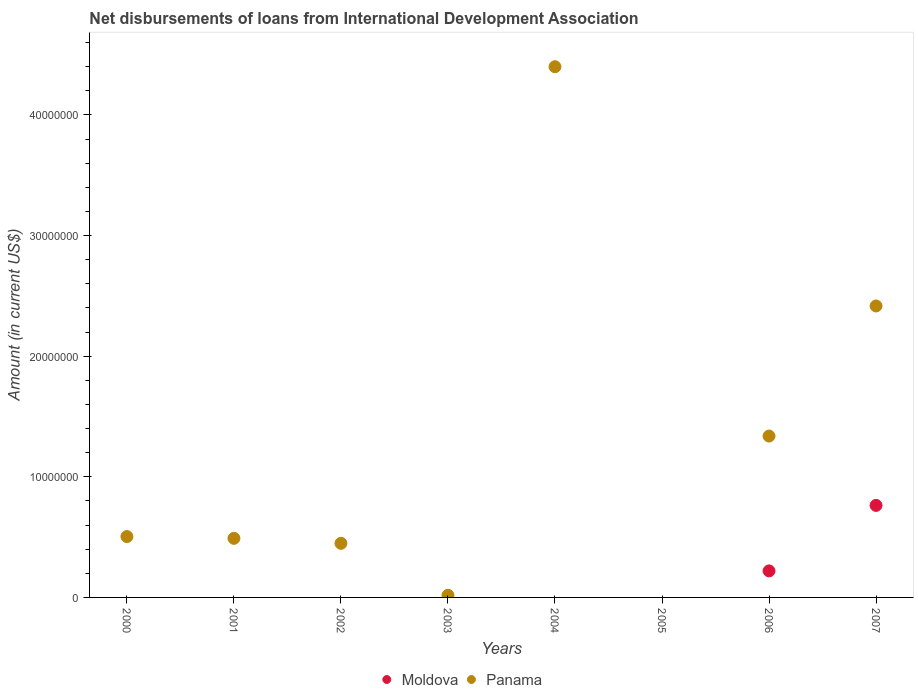Is the number of dotlines equal to the number of legend labels?
Offer a very short reply. No. Across all years, what is the maximum amount of loans disbursed in Panama?
Provide a succinct answer. 4.40e+07. What is the total amount of loans disbursed in Panama in the graph?
Keep it short and to the point. 9.61e+07. What is the difference between the amount of loans disbursed in Panama in 2004 and that in 2006?
Provide a succinct answer. 3.06e+07. What is the difference between the amount of loans disbursed in Panama in 2004 and the amount of loans disbursed in Moldova in 2000?
Make the answer very short. 4.40e+07. What is the average amount of loans disbursed in Panama per year?
Offer a very short reply. 1.20e+07. In how many years, is the amount of loans disbursed in Moldova greater than 30000000 US$?
Keep it short and to the point. 0. What is the ratio of the amount of loans disbursed in Panama in 2000 to that in 2007?
Offer a terse response. 0.21. What is the difference between the highest and the second highest amount of loans disbursed in Panama?
Give a very brief answer. 1.98e+07. What is the difference between the highest and the lowest amount of loans disbursed in Panama?
Your answer should be very brief. 4.40e+07. Is the sum of the amount of loans disbursed in Panama in 2006 and 2007 greater than the maximum amount of loans disbursed in Moldova across all years?
Provide a short and direct response. Yes. Is the amount of loans disbursed in Moldova strictly greater than the amount of loans disbursed in Panama over the years?
Your answer should be very brief. No. How many dotlines are there?
Offer a terse response. 2. Does the graph contain any zero values?
Provide a short and direct response. Yes. Does the graph contain grids?
Provide a succinct answer. No. How many legend labels are there?
Your answer should be very brief. 2. How are the legend labels stacked?
Ensure brevity in your answer.  Horizontal. What is the title of the graph?
Provide a short and direct response. Net disbursements of loans from International Development Association. What is the label or title of the X-axis?
Provide a short and direct response. Years. What is the label or title of the Y-axis?
Give a very brief answer. Amount (in current US$). What is the Amount (in current US$) of Moldova in 2000?
Your response must be concise. 0. What is the Amount (in current US$) of Panama in 2000?
Offer a terse response. 5.05e+06. What is the Amount (in current US$) of Panama in 2001?
Your answer should be very brief. 4.90e+06. What is the Amount (in current US$) of Moldova in 2002?
Provide a short and direct response. 0. What is the Amount (in current US$) of Panama in 2002?
Your answer should be very brief. 4.48e+06. What is the Amount (in current US$) of Moldova in 2003?
Provide a short and direct response. 0. What is the Amount (in current US$) in Panama in 2004?
Your answer should be very brief. 4.40e+07. What is the Amount (in current US$) of Moldova in 2006?
Ensure brevity in your answer.  2.20e+06. What is the Amount (in current US$) of Panama in 2006?
Make the answer very short. 1.34e+07. What is the Amount (in current US$) of Moldova in 2007?
Keep it short and to the point. 7.63e+06. What is the Amount (in current US$) in Panama in 2007?
Your answer should be compact. 2.42e+07. Across all years, what is the maximum Amount (in current US$) in Moldova?
Give a very brief answer. 7.63e+06. Across all years, what is the maximum Amount (in current US$) in Panama?
Your answer should be compact. 4.40e+07. Across all years, what is the minimum Amount (in current US$) of Panama?
Your response must be concise. 0. What is the total Amount (in current US$) in Moldova in the graph?
Ensure brevity in your answer.  9.83e+06. What is the total Amount (in current US$) of Panama in the graph?
Your answer should be compact. 9.61e+07. What is the difference between the Amount (in current US$) in Panama in 2000 and that in 2001?
Make the answer very short. 1.49e+05. What is the difference between the Amount (in current US$) of Panama in 2000 and that in 2002?
Provide a short and direct response. 5.61e+05. What is the difference between the Amount (in current US$) of Panama in 2000 and that in 2003?
Make the answer very short. 4.87e+06. What is the difference between the Amount (in current US$) of Panama in 2000 and that in 2004?
Your answer should be compact. -3.90e+07. What is the difference between the Amount (in current US$) of Panama in 2000 and that in 2006?
Provide a succinct answer. -8.33e+06. What is the difference between the Amount (in current US$) in Panama in 2000 and that in 2007?
Give a very brief answer. -1.91e+07. What is the difference between the Amount (in current US$) in Panama in 2001 and that in 2002?
Your response must be concise. 4.12e+05. What is the difference between the Amount (in current US$) in Panama in 2001 and that in 2003?
Provide a short and direct response. 4.72e+06. What is the difference between the Amount (in current US$) of Panama in 2001 and that in 2004?
Offer a terse response. -3.91e+07. What is the difference between the Amount (in current US$) of Panama in 2001 and that in 2006?
Give a very brief answer. -8.48e+06. What is the difference between the Amount (in current US$) in Panama in 2001 and that in 2007?
Provide a short and direct response. -1.93e+07. What is the difference between the Amount (in current US$) in Panama in 2002 and that in 2003?
Make the answer very short. 4.30e+06. What is the difference between the Amount (in current US$) in Panama in 2002 and that in 2004?
Your answer should be very brief. -3.95e+07. What is the difference between the Amount (in current US$) of Panama in 2002 and that in 2006?
Give a very brief answer. -8.89e+06. What is the difference between the Amount (in current US$) in Panama in 2002 and that in 2007?
Offer a very short reply. -1.97e+07. What is the difference between the Amount (in current US$) of Panama in 2003 and that in 2004?
Offer a very short reply. -4.38e+07. What is the difference between the Amount (in current US$) in Panama in 2003 and that in 2006?
Keep it short and to the point. -1.32e+07. What is the difference between the Amount (in current US$) of Panama in 2003 and that in 2007?
Provide a short and direct response. -2.40e+07. What is the difference between the Amount (in current US$) of Panama in 2004 and that in 2006?
Keep it short and to the point. 3.06e+07. What is the difference between the Amount (in current US$) of Panama in 2004 and that in 2007?
Your answer should be compact. 1.98e+07. What is the difference between the Amount (in current US$) in Moldova in 2006 and that in 2007?
Offer a terse response. -5.43e+06. What is the difference between the Amount (in current US$) in Panama in 2006 and that in 2007?
Give a very brief answer. -1.08e+07. What is the difference between the Amount (in current US$) of Moldova in 2006 and the Amount (in current US$) of Panama in 2007?
Your answer should be very brief. -2.20e+07. What is the average Amount (in current US$) of Moldova per year?
Ensure brevity in your answer.  1.23e+06. What is the average Amount (in current US$) of Panama per year?
Your response must be concise. 1.20e+07. In the year 2006, what is the difference between the Amount (in current US$) of Moldova and Amount (in current US$) of Panama?
Your response must be concise. -1.12e+07. In the year 2007, what is the difference between the Amount (in current US$) in Moldova and Amount (in current US$) in Panama?
Your response must be concise. -1.65e+07. What is the ratio of the Amount (in current US$) in Panama in 2000 to that in 2001?
Your answer should be compact. 1.03. What is the ratio of the Amount (in current US$) in Panama in 2000 to that in 2002?
Make the answer very short. 1.13. What is the ratio of the Amount (in current US$) in Panama in 2000 to that in 2003?
Make the answer very short. 28.03. What is the ratio of the Amount (in current US$) in Panama in 2000 to that in 2004?
Your response must be concise. 0.11. What is the ratio of the Amount (in current US$) in Panama in 2000 to that in 2006?
Your answer should be compact. 0.38. What is the ratio of the Amount (in current US$) in Panama in 2000 to that in 2007?
Keep it short and to the point. 0.21. What is the ratio of the Amount (in current US$) of Panama in 2001 to that in 2002?
Provide a succinct answer. 1.09. What is the ratio of the Amount (in current US$) in Panama in 2001 to that in 2003?
Your response must be concise. 27.21. What is the ratio of the Amount (in current US$) in Panama in 2001 to that in 2004?
Ensure brevity in your answer.  0.11. What is the ratio of the Amount (in current US$) in Panama in 2001 to that in 2006?
Your answer should be very brief. 0.37. What is the ratio of the Amount (in current US$) of Panama in 2001 to that in 2007?
Keep it short and to the point. 0.2. What is the ratio of the Amount (in current US$) in Panama in 2002 to that in 2003?
Provide a succinct answer. 24.92. What is the ratio of the Amount (in current US$) of Panama in 2002 to that in 2004?
Offer a very short reply. 0.1. What is the ratio of the Amount (in current US$) of Panama in 2002 to that in 2006?
Your response must be concise. 0.34. What is the ratio of the Amount (in current US$) of Panama in 2002 to that in 2007?
Offer a very short reply. 0.19. What is the ratio of the Amount (in current US$) in Panama in 2003 to that in 2004?
Give a very brief answer. 0. What is the ratio of the Amount (in current US$) in Panama in 2003 to that in 2006?
Keep it short and to the point. 0.01. What is the ratio of the Amount (in current US$) of Panama in 2003 to that in 2007?
Give a very brief answer. 0.01. What is the ratio of the Amount (in current US$) of Panama in 2004 to that in 2006?
Give a very brief answer. 3.29. What is the ratio of the Amount (in current US$) in Panama in 2004 to that in 2007?
Your response must be concise. 1.82. What is the ratio of the Amount (in current US$) of Moldova in 2006 to that in 2007?
Ensure brevity in your answer.  0.29. What is the ratio of the Amount (in current US$) of Panama in 2006 to that in 2007?
Give a very brief answer. 0.55. What is the difference between the highest and the second highest Amount (in current US$) in Panama?
Offer a terse response. 1.98e+07. What is the difference between the highest and the lowest Amount (in current US$) in Moldova?
Make the answer very short. 7.63e+06. What is the difference between the highest and the lowest Amount (in current US$) in Panama?
Ensure brevity in your answer.  4.40e+07. 